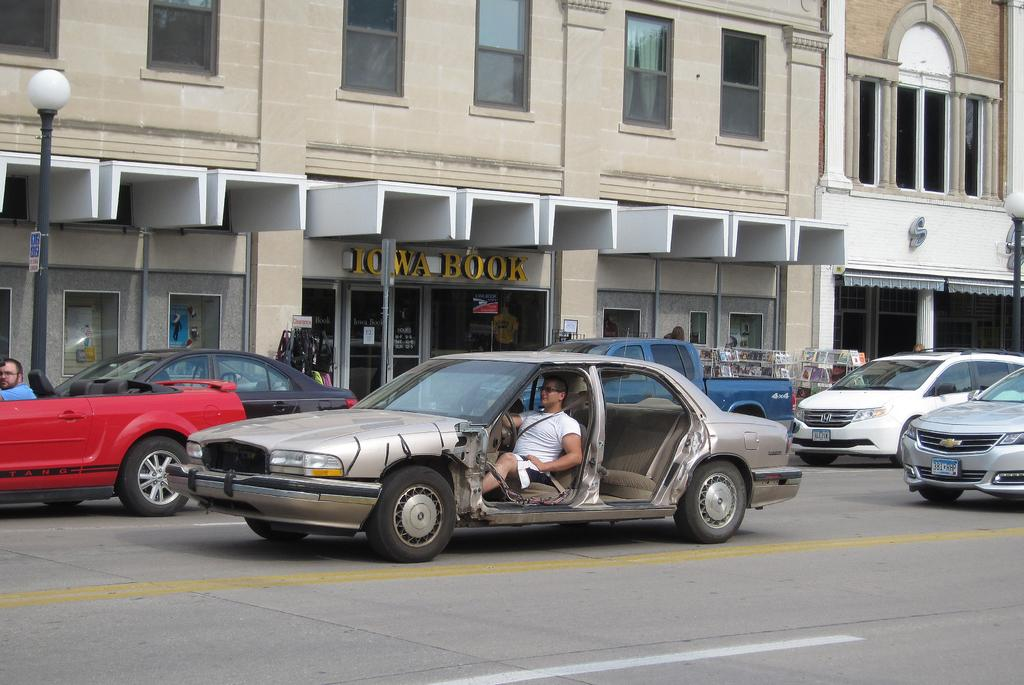What types of objects are present in the image? There are vehicles, persons, buildings, windows, and lights on poles in the image. Can you describe the vehicles in the image? There are persons in the vehicles, but the specific types of vehicles are not mentioned. What can be seen inside the buildings in the image? The information provided does not specify what can be seen inside the buildings. How many windows are visible in the image? The number of windows visible in the image is not mentioned. What is the purpose of the lights on poles in the image? The purpose of the lights on poles is not mentioned, but they are likely for illumination. What type of pancake is being served at the battle depicted in the image? There is no battle or pancake depicted in the image; it features vehicles, persons, buildings, windows, and lights on poles. How many stamps are visible on the vehicles in the image? There is no mention of stamps on the vehicles in the image. 